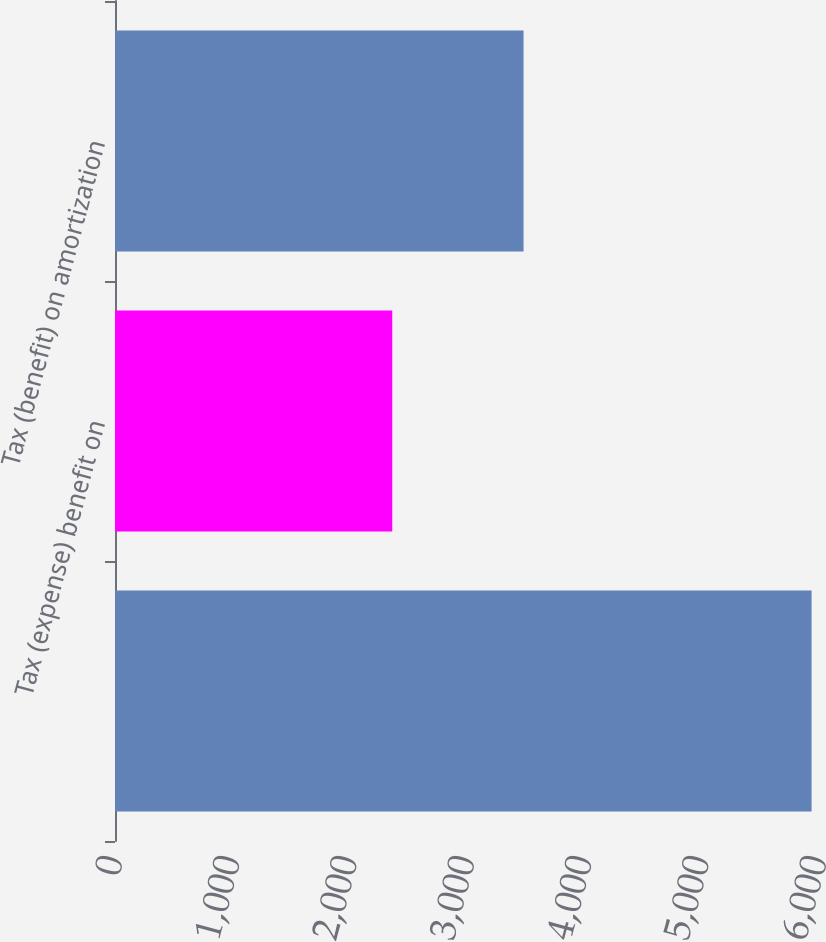Convert chart to OTSL. <chart><loc_0><loc_0><loc_500><loc_500><bar_chart><ecel><fcel>Tax (expense) benefit on<fcel>Tax (benefit) on amortization<nl><fcel>5936.8<fcel>2363<fcel>3482<nl></chart> 